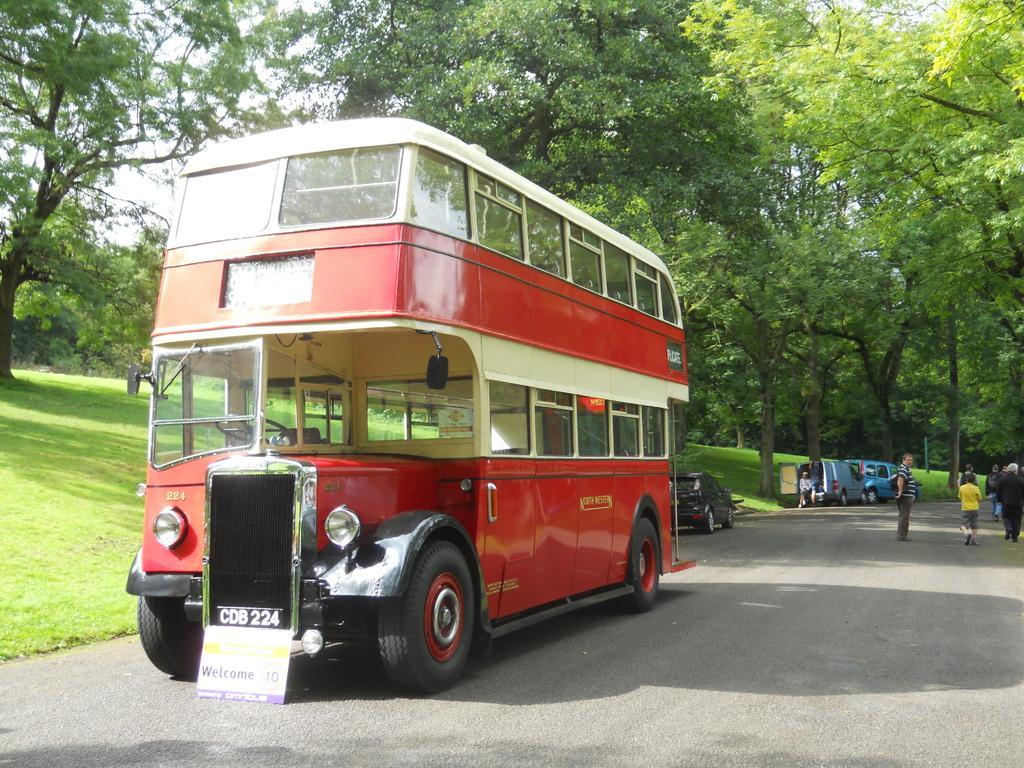How would you summarize this image in a sentence or two? On the left side, there are vehicles on the road, there are trees and there's grass on the ground. On the right side, there are persons on the road. In the background, there are trees and there is sky. 